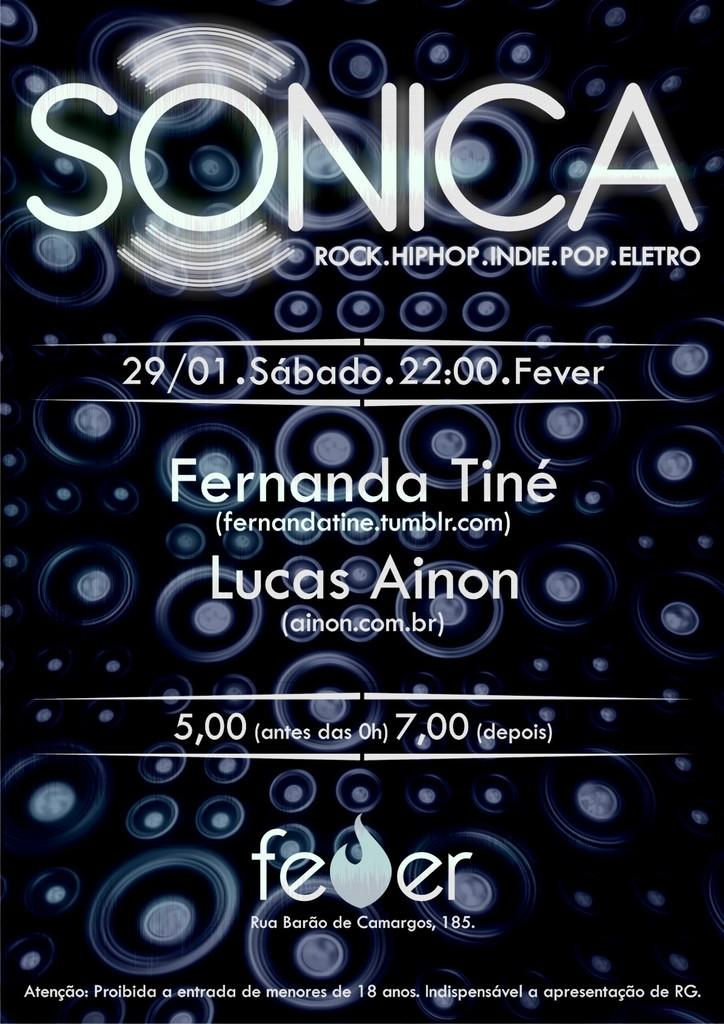Provide a one-sentence caption for the provided image. A SONICA poster advertises an upcoming music event. 